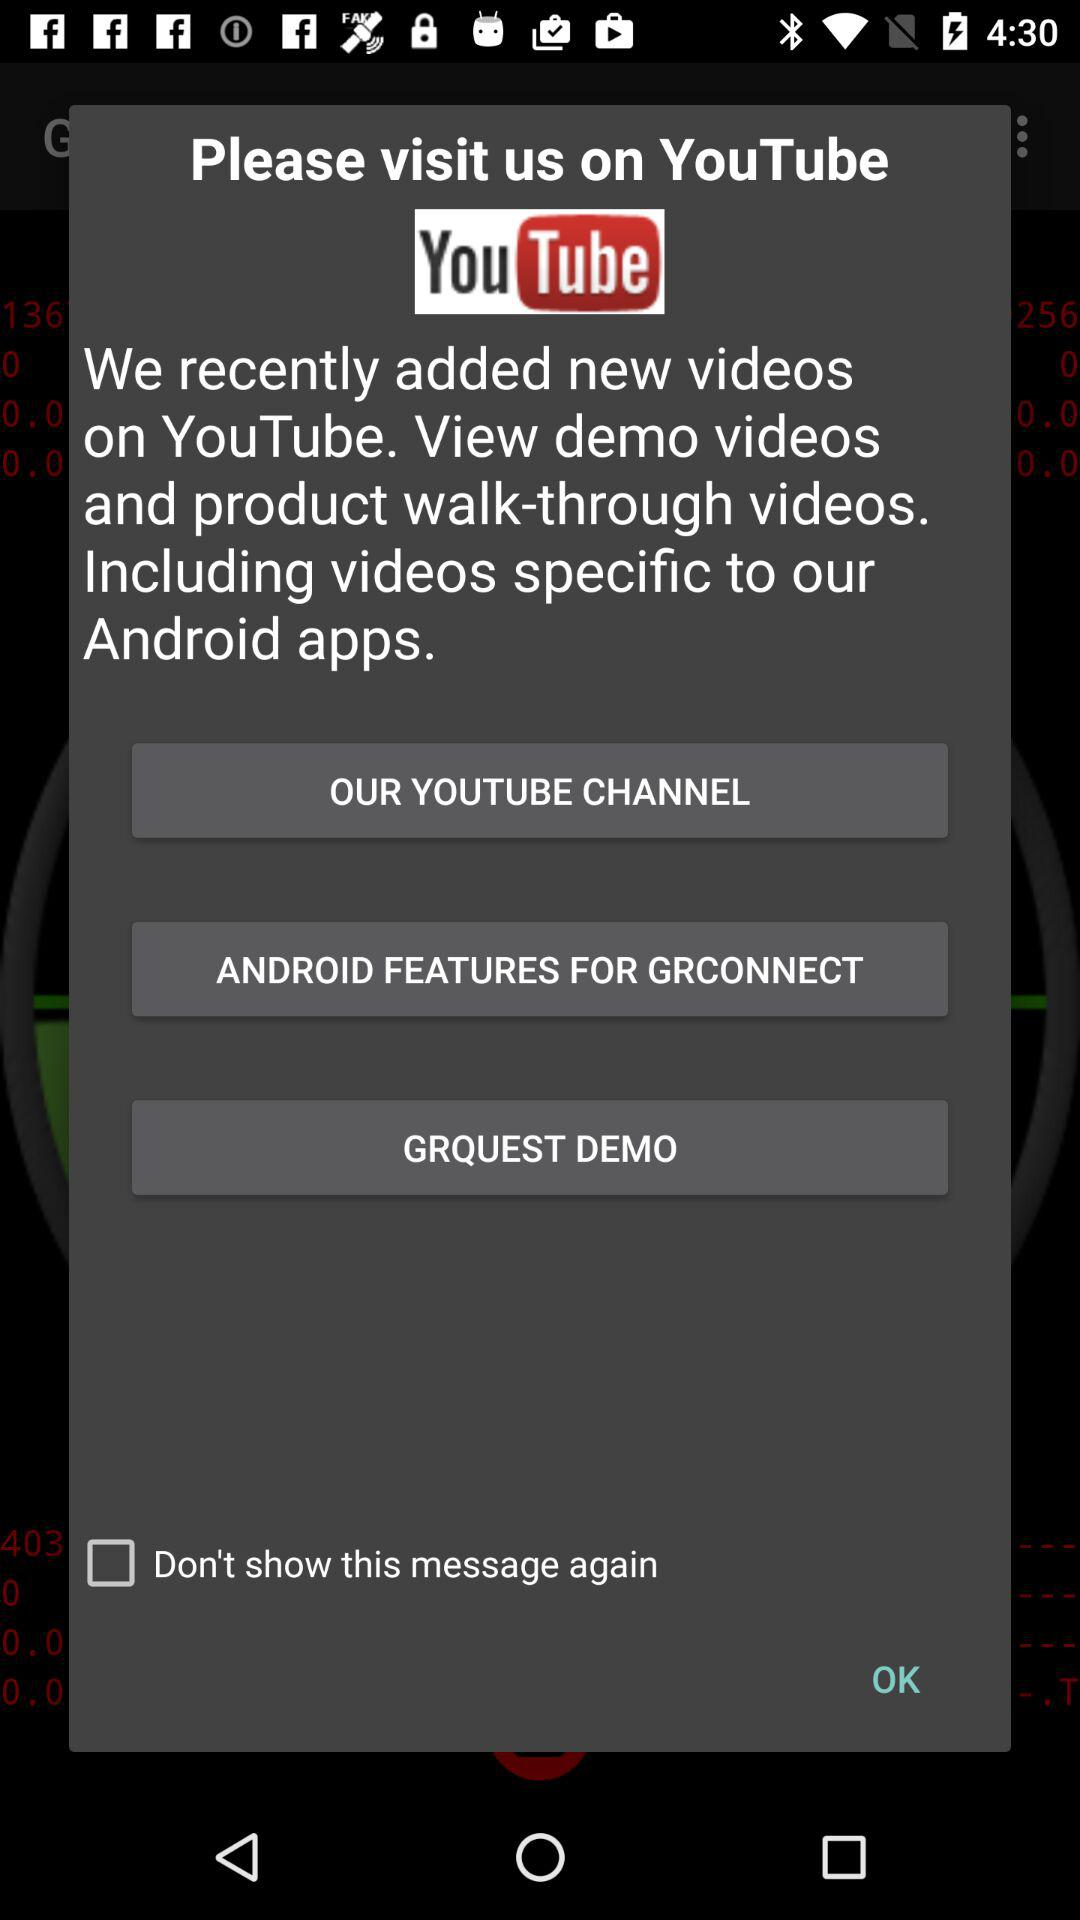What is the status of the "Don't show this message again"? The status is off. 